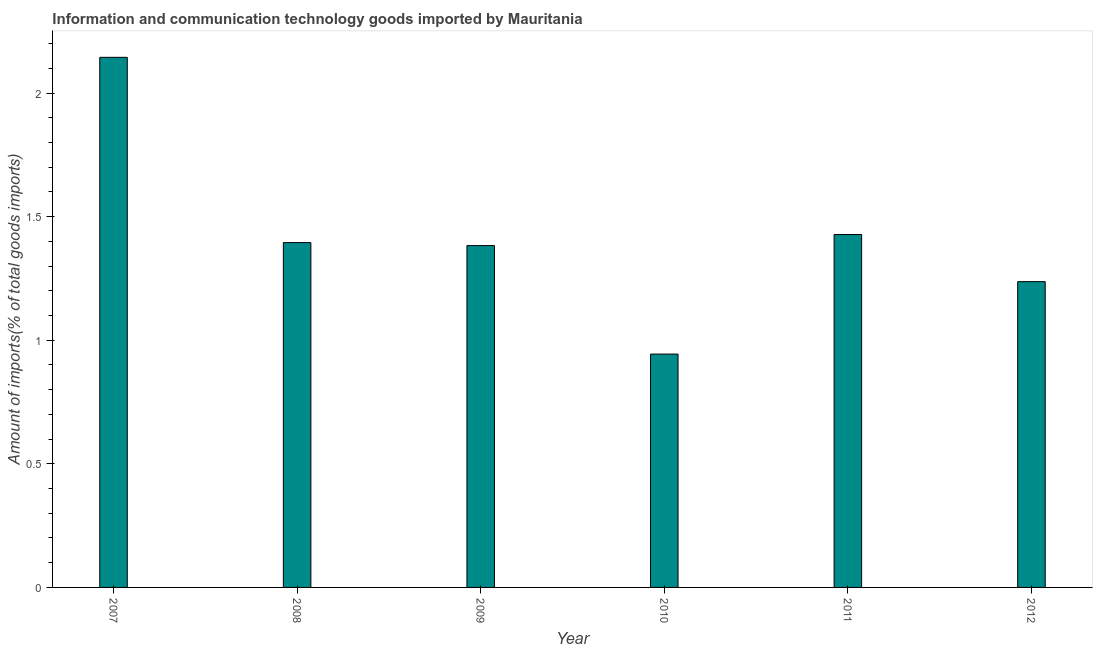What is the title of the graph?
Keep it short and to the point. Information and communication technology goods imported by Mauritania. What is the label or title of the X-axis?
Make the answer very short. Year. What is the label or title of the Y-axis?
Offer a very short reply. Amount of imports(% of total goods imports). What is the amount of ict goods imports in 2011?
Give a very brief answer. 1.43. Across all years, what is the maximum amount of ict goods imports?
Your answer should be very brief. 2.14. Across all years, what is the minimum amount of ict goods imports?
Offer a very short reply. 0.94. In which year was the amount of ict goods imports minimum?
Your answer should be very brief. 2010. What is the sum of the amount of ict goods imports?
Make the answer very short. 8.53. What is the difference between the amount of ict goods imports in 2007 and 2010?
Ensure brevity in your answer.  1.2. What is the average amount of ict goods imports per year?
Your response must be concise. 1.42. What is the median amount of ict goods imports?
Make the answer very short. 1.39. What is the ratio of the amount of ict goods imports in 2008 to that in 2009?
Offer a very short reply. 1.01. Is the difference between the amount of ict goods imports in 2010 and 2011 greater than the difference between any two years?
Your response must be concise. No. What is the difference between the highest and the second highest amount of ict goods imports?
Your answer should be compact. 0.72. Is the sum of the amount of ict goods imports in 2010 and 2011 greater than the maximum amount of ict goods imports across all years?
Ensure brevity in your answer.  Yes. Are all the bars in the graph horizontal?
Your answer should be compact. No. How many years are there in the graph?
Your response must be concise. 6. What is the difference between two consecutive major ticks on the Y-axis?
Make the answer very short. 0.5. Are the values on the major ticks of Y-axis written in scientific E-notation?
Ensure brevity in your answer.  No. What is the Amount of imports(% of total goods imports) in 2007?
Give a very brief answer. 2.14. What is the Amount of imports(% of total goods imports) in 2008?
Provide a succinct answer. 1.4. What is the Amount of imports(% of total goods imports) of 2009?
Your answer should be very brief. 1.38. What is the Amount of imports(% of total goods imports) of 2010?
Offer a terse response. 0.94. What is the Amount of imports(% of total goods imports) in 2011?
Ensure brevity in your answer.  1.43. What is the Amount of imports(% of total goods imports) of 2012?
Provide a succinct answer. 1.24. What is the difference between the Amount of imports(% of total goods imports) in 2007 and 2008?
Your answer should be compact. 0.75. What is the difference between the Amount of imports(% of total goods imports) in 2007 and 2009?
Provide a succinct answer. 0.76. What is the difference between the Amount of imports(% of total goods imports) in 2007 and 2010?
Keep it short and to the point. 1.2. What is the difference between the Amount of imports(% of total goods imports) in 2007 and 2011?
Your response must be concise. 0.72. What is the difference between the Amount of imports(% of total goods imports) in 2007 and 2012?
Provide a succinct answer. 0.91. What is the difference between the Amount of imports(% of total goods imports) in 2008 and 2009?
Make the answer very short. 0.01. What is the difference between the Amount of imports(% of total goods imports) in 2008 and 2010?
Make the answer very short. 0.45. What is the difference between the Amount of imports(% of total goods imports) in 2008 and 2011?
Provide a succinct answer. -0.03. What is the difference between the Amount of imports(% of total goods imports) in 2008 and 2012?
Your answer should be very brief. 0.16. What is the difference between the Amount of imports(% of total goods imports) in 2009 and 2010?
Give a very brief answer. 0.44. What is the difference between the Amount of imports(% of total goods imports) in 2009 and 2011?
Ensure brevity in your answer.  -0.04. What is the difference between the Amount of imports(% of total goods imports) in 2009 and 2012?
Give a very brief answer. 0.15. What is the difference between the Amount of imports(% of total goods imports) in 2010 and 2011?
Provide a short and direct response. -0.48. What is the difference between the Amount of imports(% of total goods imports) in 2010 and 2012?
Your answer should be compact. -0.29. What is the difference between the Amount of imports(% of total goods imports) in 2011 and 2012?
Give a very brief answer. 0.19. What is the ratio of the Amount of imports(% of total goods imports) in 2007 to that in 2008?
Make the answer very short. 1.54. What is the ratio of the Amount of imports(% of total goods imports) in 2007 to that in 2009?
Keep it short and to the point. 1.55. What is the ratio of the Amount of imports(% of total goods imports) in 2007 to that in 2010?
Make the answer very short. 2.27. What is the ratio of the Amount of imports(% of total goods imports) in 2007 to that in 2011?
Provide a succinct answer. 1.5. What is the ratio of the Amount of imports(% of total goods imports) in 2007 to that in 2012?
Your answer should be very brief. 1.73. What is the ratio of the Amount of imports(% of total goods imports) in 2008 to that in 2010?
Offer a terse response. 1.48. What is the ratio of the Amount of imports(% of total goods imports) in 2008 to that in 2011?
Your answer should be compact. 0.98. What is the ratio of the Amount of imports(% of total goods imports) in 2008 to that in 2012?
Your answer should be compact. 1.13. What is the ratio of the Amount of imports(% of total goods imports) in 2009 to that in 2010?
Your answer should be very brief. 1.47. What is the ratio of the Amount of imports(% of total goods imports) in 2009 to that in 2011?
Provide a succinct answer. 0.97. What is the ratio of the Amount of imports(% of total goods imports) in 2009 to that in 2012?
Give a very brief answer. 1.12. What is the ratio of the Amount of imports(% of total goods imports) in 2010 to that in 2011?
Offer a very short reply. 0.66. What is the ratio of the Amount of imports(% of total goods imports) in 2010 to that in 2012?
Ensure brevity in your answer.  0.76. What is the ratio of the Amount of imports(% of total goods imports) in 2011 to that in 2012?
Make the answer very short. 1.15. 